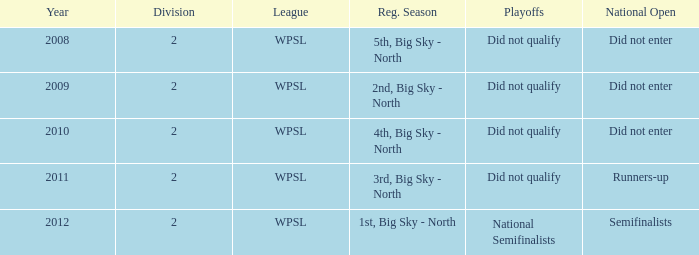What is the highest number of divisions mentioned? 2.0. 